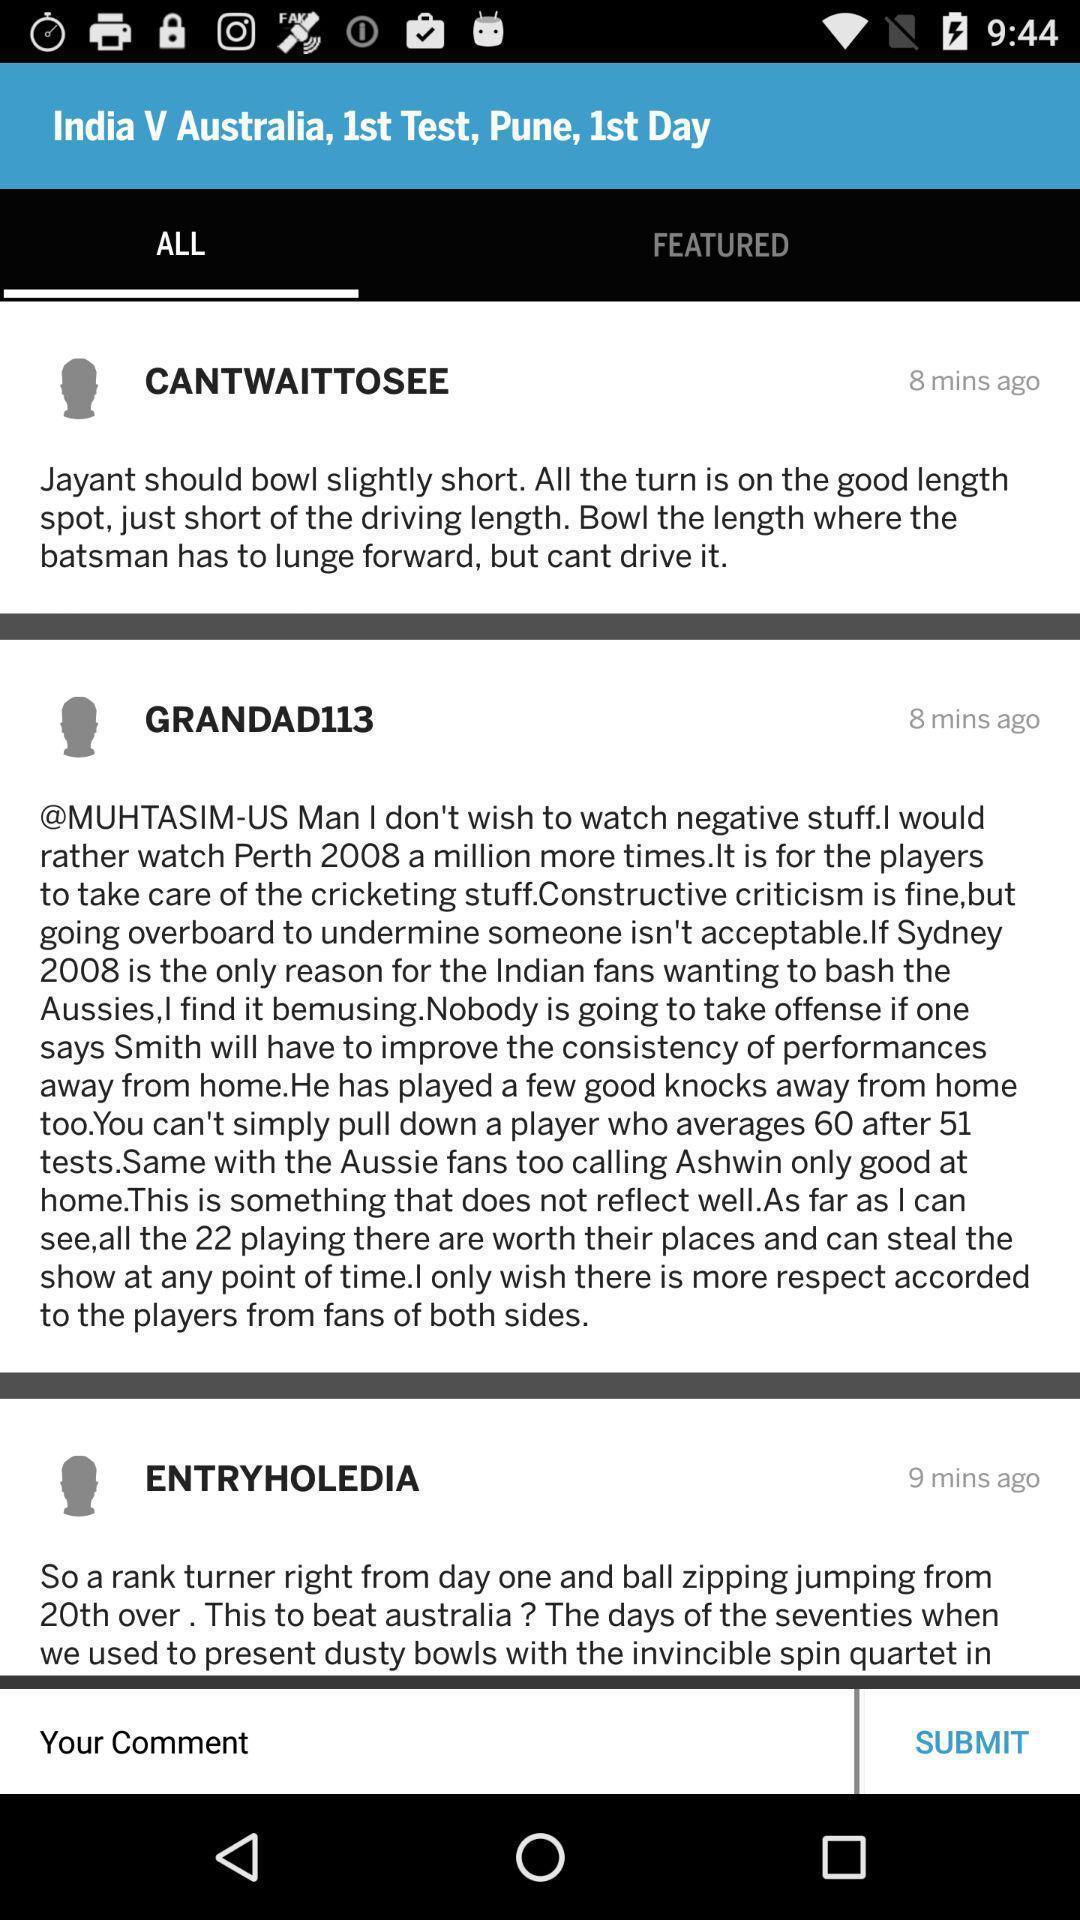Tell me about the visual elements in this screen capture. Various feed displayed regarding a game in a sports app. 